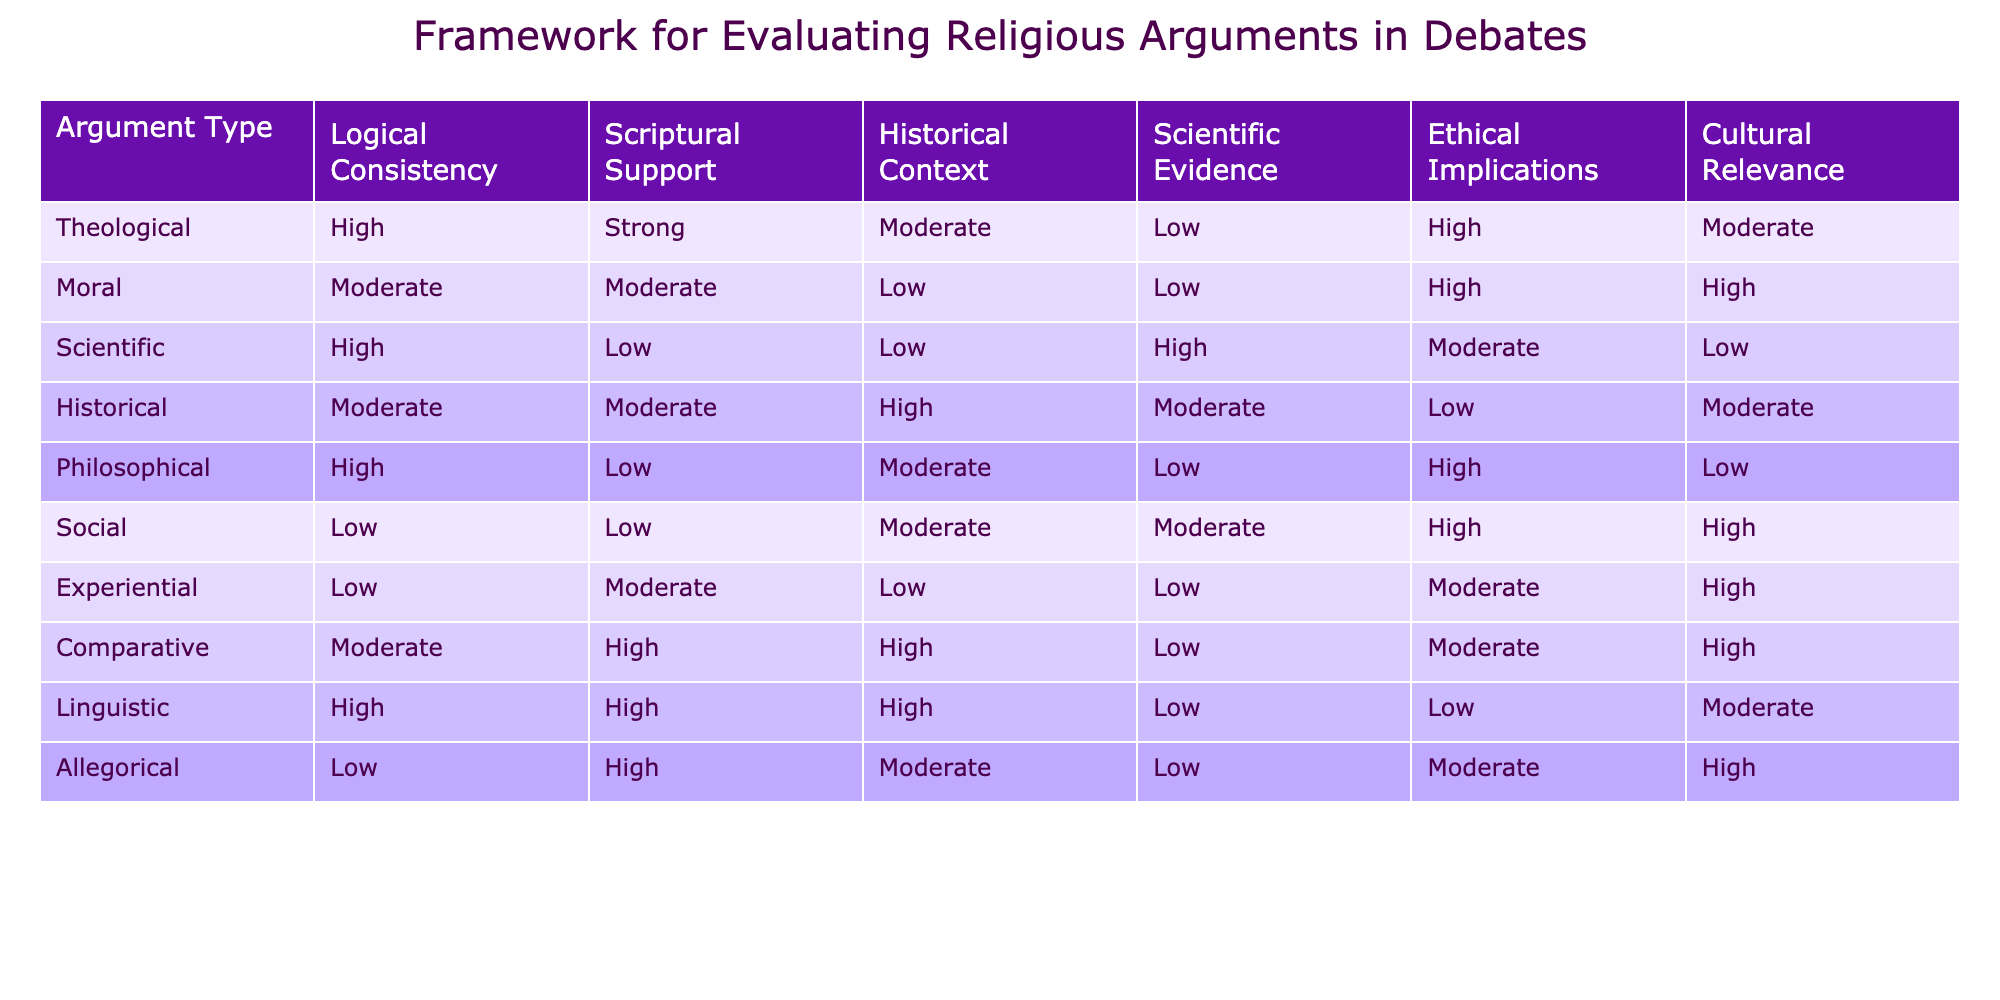What argument type has the highest logical consistency? In the table, the "Logical Consistency" column shows that the "Theological" argument type has a value of "High." This is the highest rating in that column.
Answer: Theological How many argument types have moderate ethical implications? By counting the "Ethical Implications" column, we find that there are three argument types (Moral, Historical, and Comparative) with a rating of "Moderate."
Answer: 3 Is there any argument type that has low cultural relevance? Looking at the "Cultural Relevance" column, I can see that both the Scientific and Philosophical argument types have a value of "Low." So the answer is yes.
Answer: Yes Which argument types have strong scriptural support? In the "Scriptural Support" column, both "Theological" and "Comparative" argument types have a value of "Strong." Therefore, these two types are the answer.
Answer: Theological, Comparative What is the average rating of historical context across all argument types? To find the average, I can assign numerical values to the ratings (High = 3, Moderate = 2, Low = 1). The values for historical context are Moderate (2), Low (1), Moderate (2), High (3), Moderate (2), Moderate (2), Low (1), High (3), Moderate (2). Summing these gives 2 + 1 + 2 + 3 + 2 + 2 + 1 + 3 + 2 = 18. There are 9 total types, so the average is 18/9 = 2.
Answer: 2 Which argument type has the lowest overall proportion of high ratings across all criteria? I assess the proportions of "High," "Moderate," and "Low" for each argument type. The "Social" argument type has a low "Logical Consistency" and "Scriptural Support," which makes it have the lowest overall proportion of high ratings.
Answer: Social How does the ethical implications of philosophical arguments compare to experiential arguments? The "Ethical Implications" for "Philosophical" is rated "High," while for "Experiential," it is "Moderate." Thus, the philosophical arguments have a better standing in terms of ethical implications.
Answer: Philosophical has higher ethical implications than Experiential 